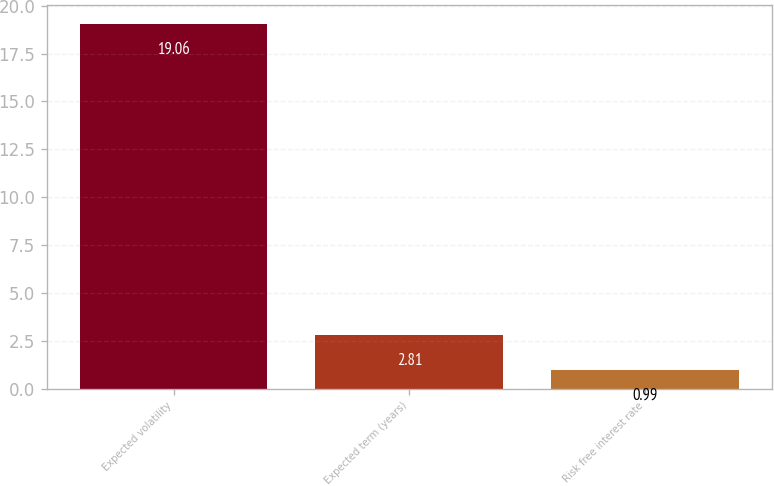Convert chart. <chart><loc_0><loc_0><loc_500><loc_500><bar_chart><fcel>Expected volatility<fcel>Expected term (years)<fcel>Risk free interest rate<nl><fcel>19.06<fcel>2.81<fcel>0.99<nl></chart> 